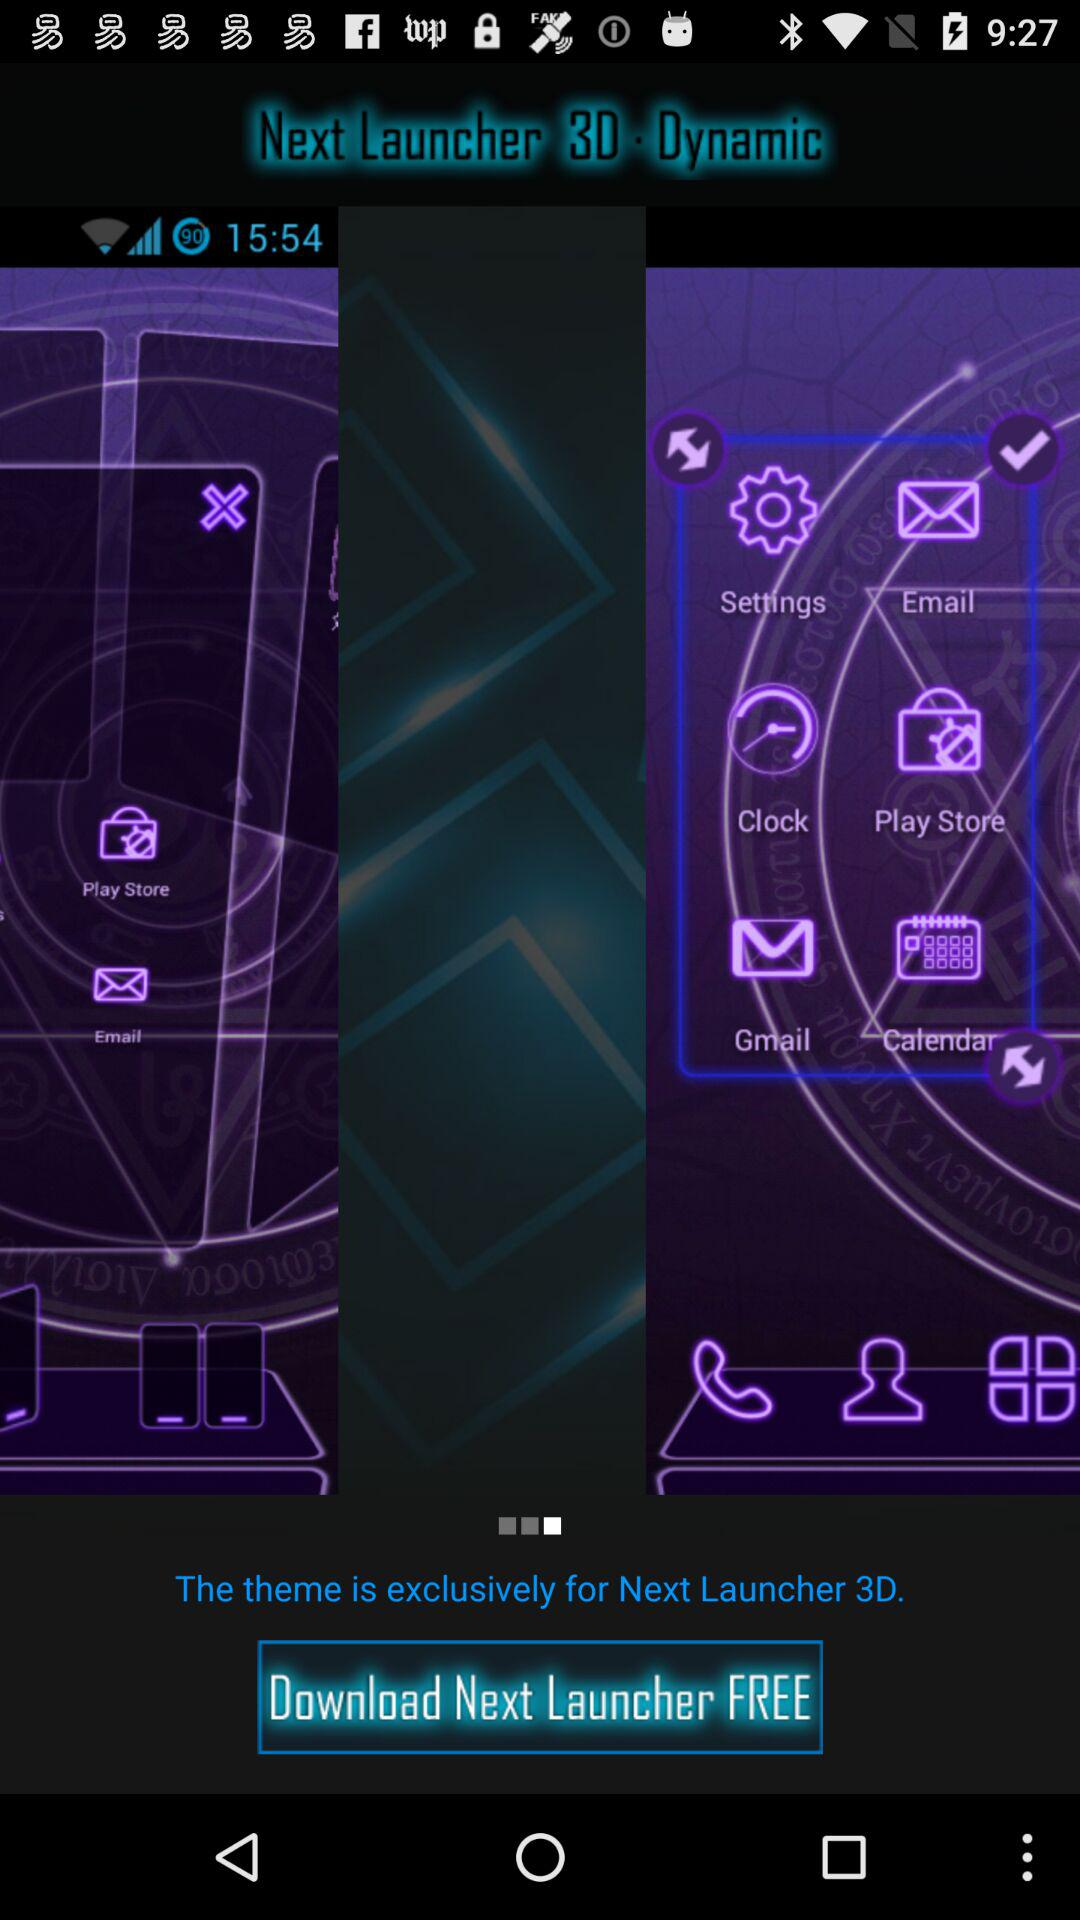What is the application name? The application name is "Next Launcher 3D". 